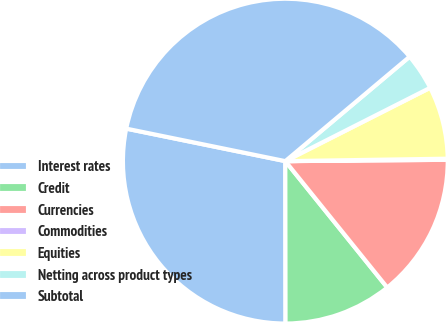<chart> <loc_0><loc_0><loc_500><loc_500><pie_chart><fcel>Interest rates<fcel>Credit<fcel>Currencies<fcel>Commodities<fcel>Equities<fcel>Netting across product types<fcel>Subtotal<nl><fcel>28.23%<fcel>10.78%<fcel>14.33%<fcel>0.11%<fcel>7.22%<fcel>3.66%<fcel>35.67%<nl></chart> 